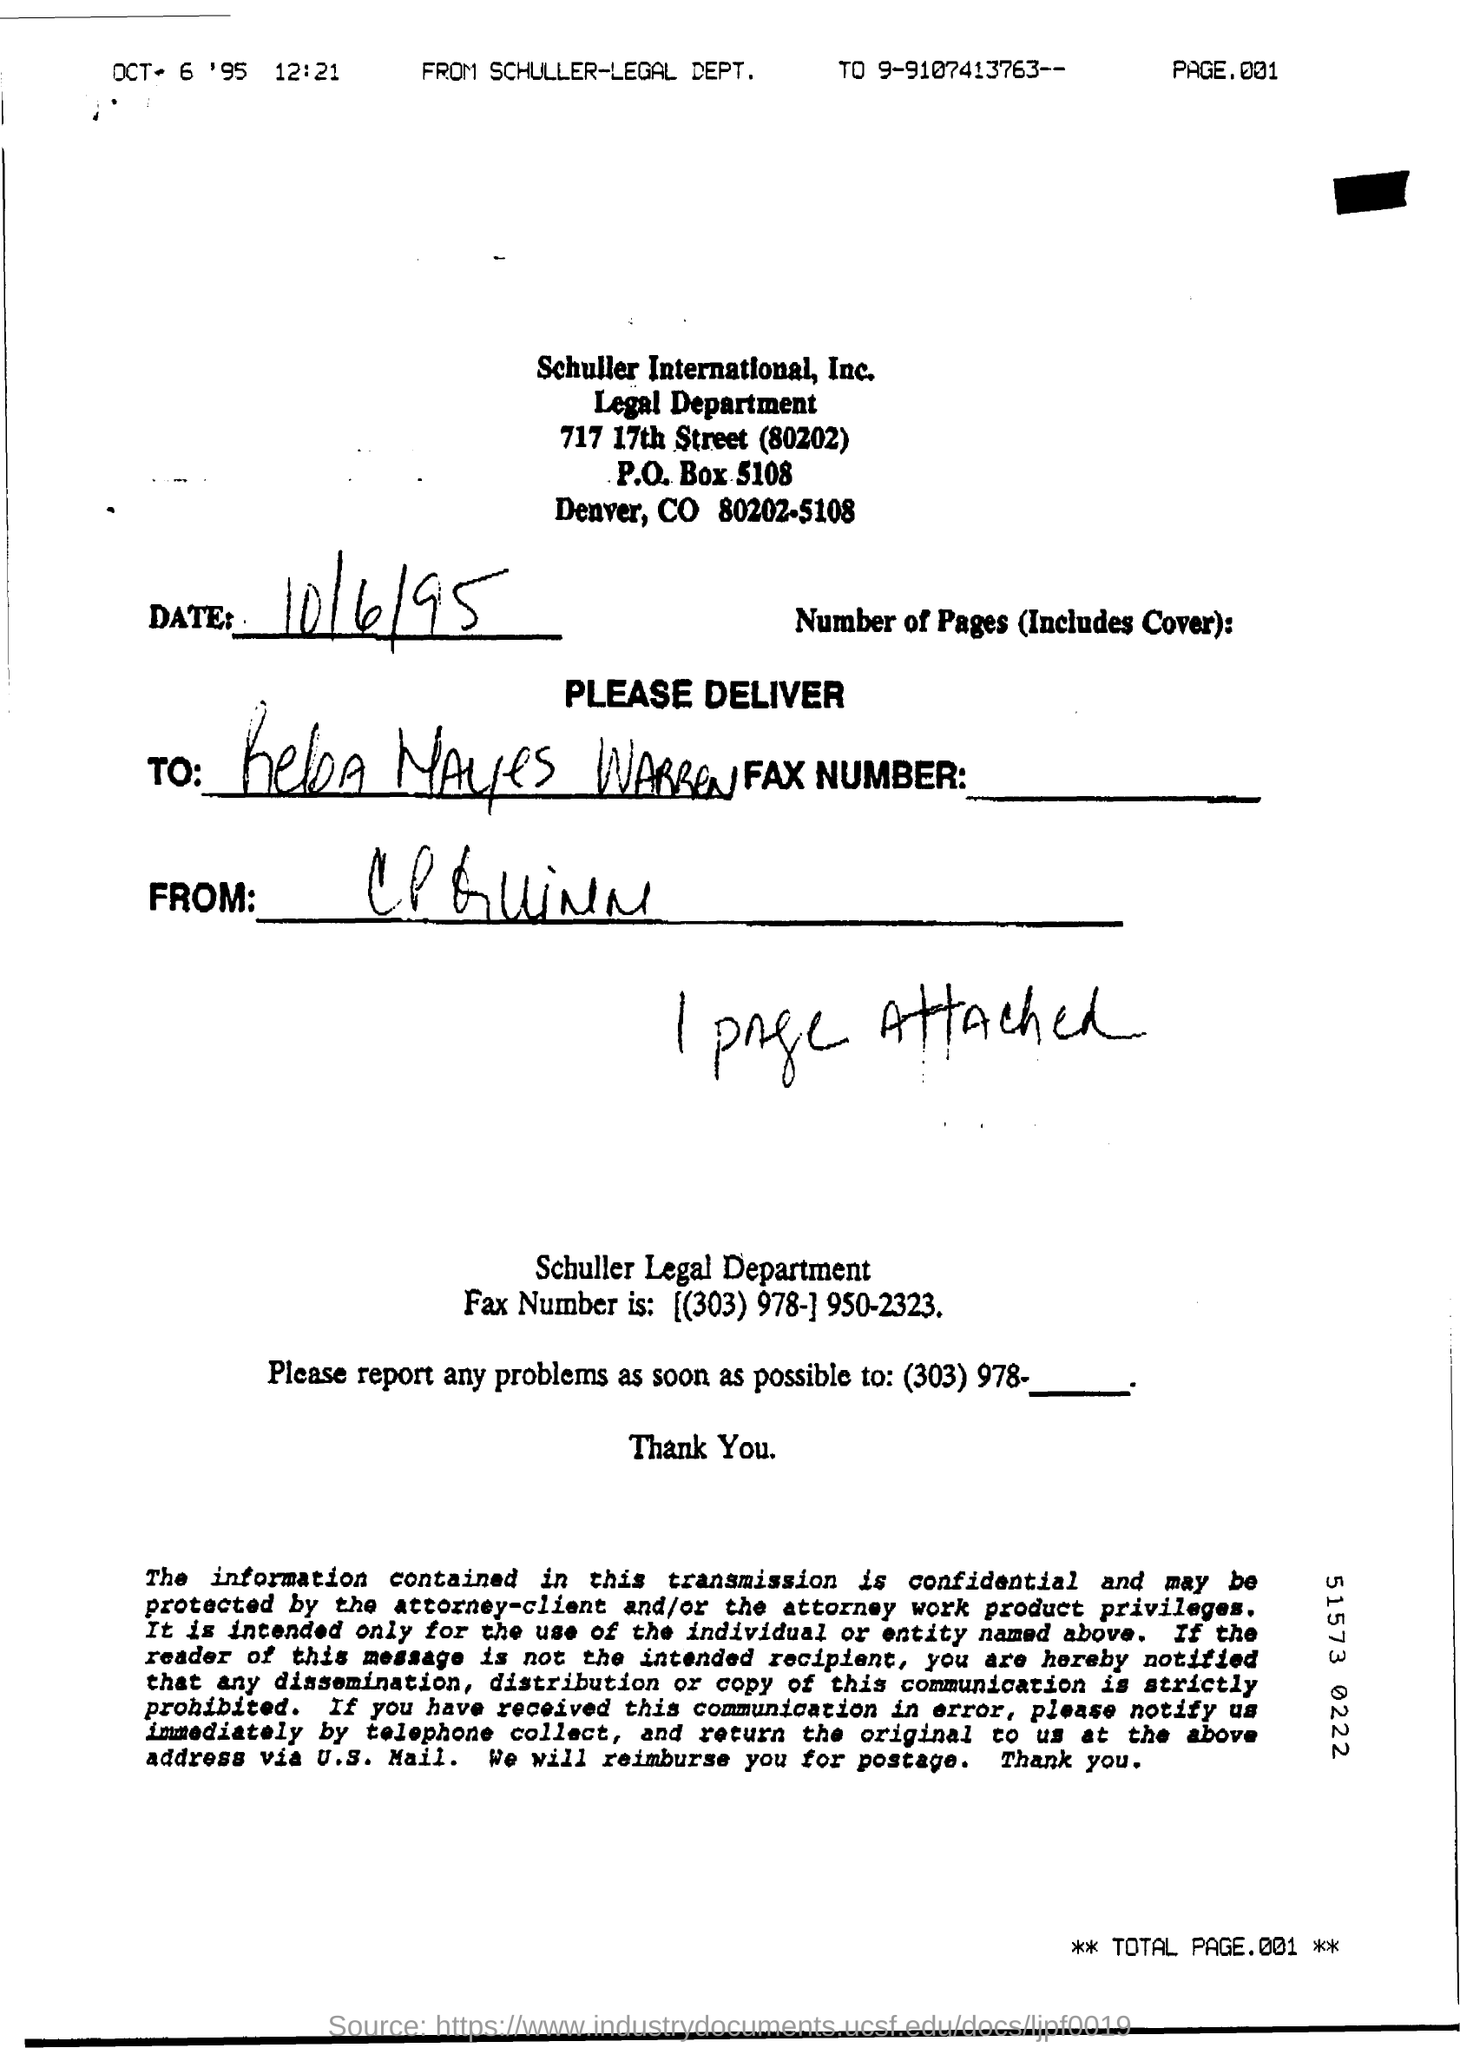Draw attention to some important aspects in this diagram. The time mentioned is 12:21. There is one page attached to the document. The page number of the document is 001. The date of the document is October 6, 1995, as specified in the text 'OCT 6 '95..'. The document was printed by the Legal Department of Schuller International Inc. Company. 